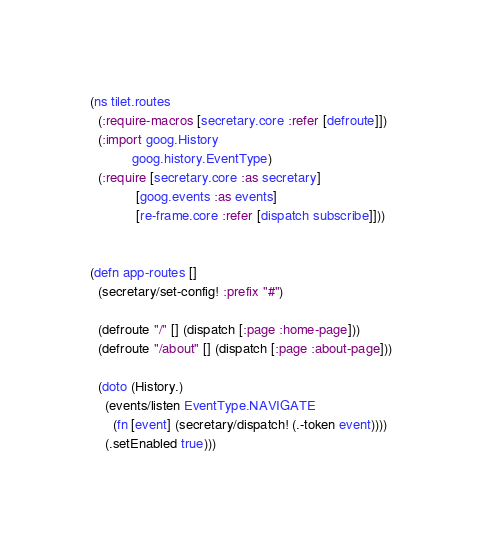<code> <loc_0><loc_0><loc_500><loc_500><_Clojure_>(ns tilet.routes
  (:require-macros [secretary.core :refer [defroute]])
  (:import goog.History
           goog.history.EventType)
  (:require [secretary.core :as secretary]
            [goog.events :as events]
            [re-frame.core :refer [dispatch subscribe]]))


(defn app-routes []
  (secretary/set-config! :prefix "#")

  (defroute "/" [] (dispatch [:page :home-page]))
  (defroute "/about" [] (dispatch [:page :about-page]))

  (doto (History.)
    (events/listen EventType.NAVIGATE
      (fn [event] (secretary/dispatch! (.-token event))))
    (.setEnabled true)))
</code> 